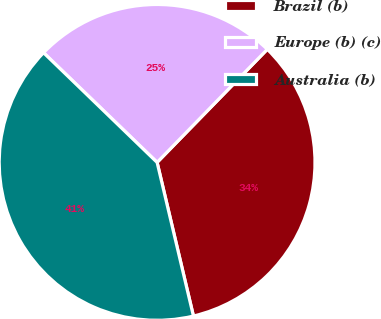<chart> <loc_0><loc_0><loc_500><loc_500><pie_chart><fcel>Brazil (b)<fcel>Europe (b) (c)<fcel>Australia (b)<nl><fcel>34.01%<fcel>25.07%<fcel>40.92%<nl></chart> 